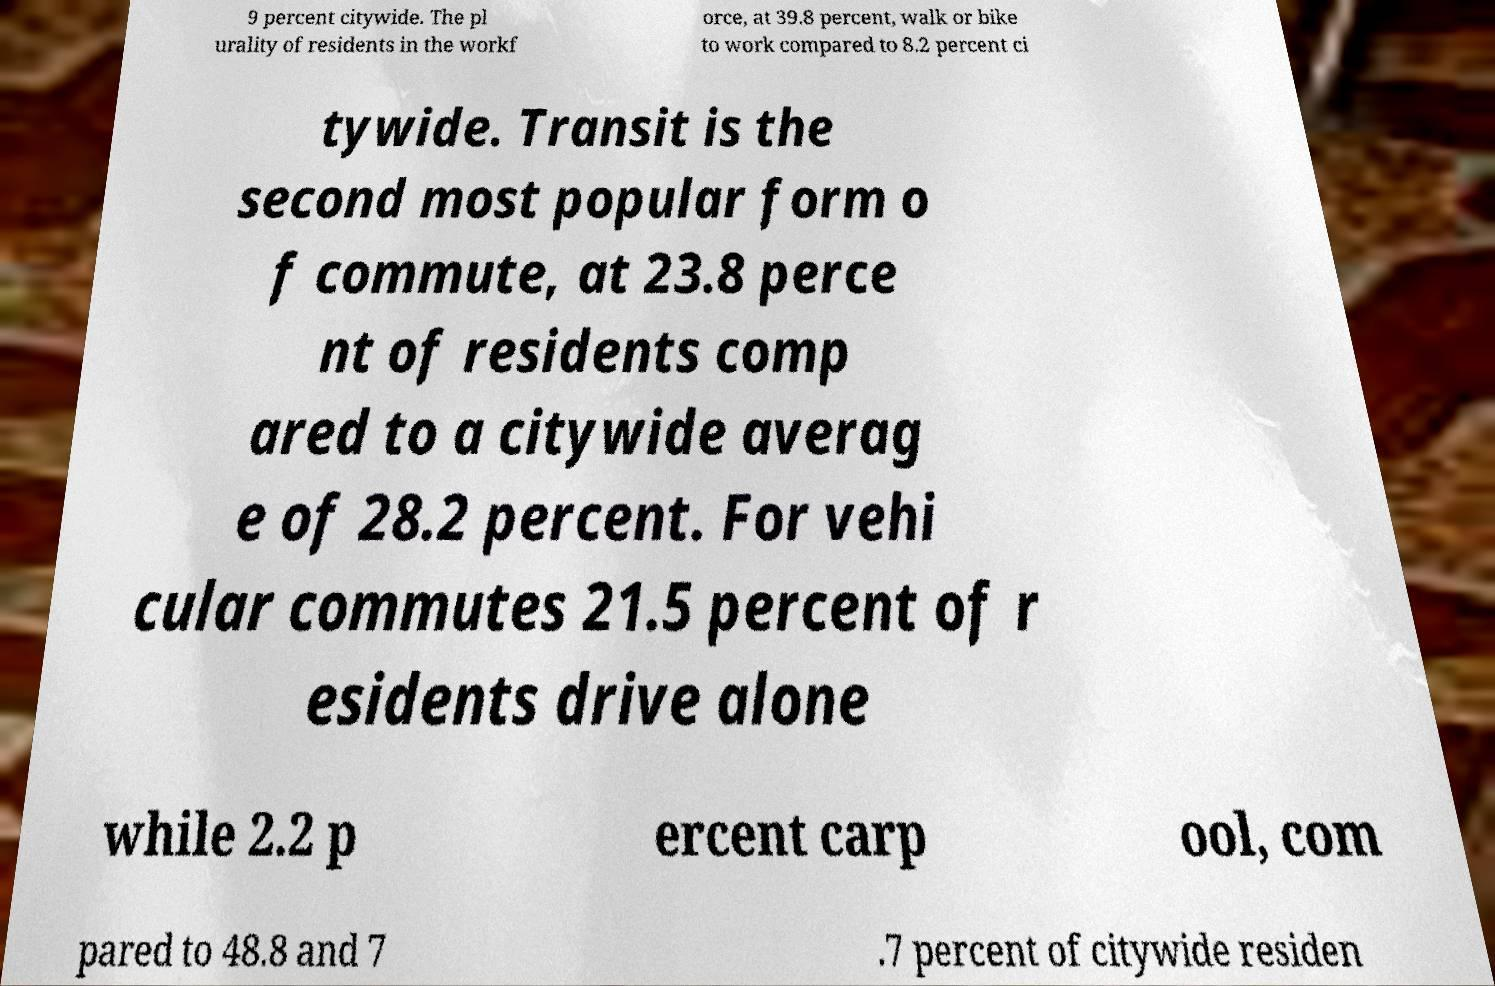Please read and relay the text visible in this image. What does it say? 9 percent citywide. The pl urality of residents in the workf orce, at 39.8 percent, walk or bike to work compared to 8.2 percent ci tywide. Transit is the second most popular form o f commute, at 23.8 perce nt of residents comp ared to a citywide averag e of 28.2 percent. For vehi cular commutes 21.5 percent of r esidents drive alone while 2.2 p ercent carp ool, com pared to 48.8 and 7 .7 percent of citywide residen 